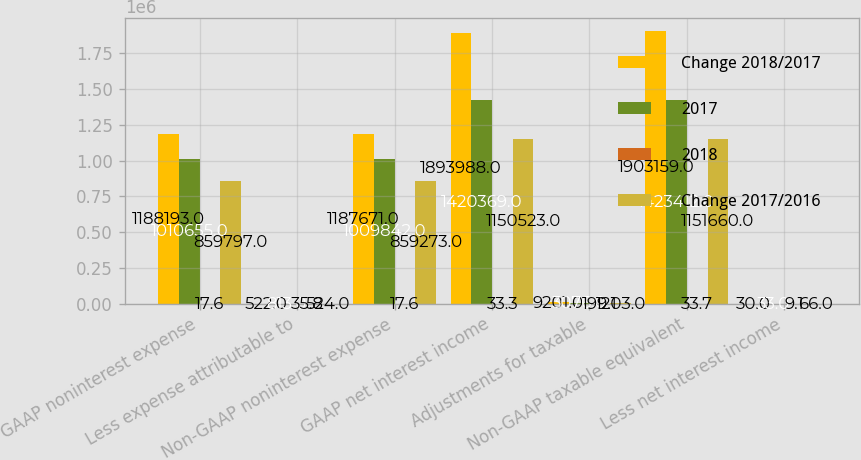<chart> <loc_0><loc_0><loc_500><loc_500><stacked_bar_chart><ecel><fcel>GAAP noninterest expense<fcel>Less expense attributable to<fcel>Non-GAAP noninterest expense<fcel>GAAP net interest income<fcel>Adjustments for taxable<fcel>Non-GAAP taxable equivalent<fcel>Less net interest income<nl><fcel>Change 2018/2017<fcel>1.18819e+06<fcel>522<fcel>1.18767e+06<fcel>1.89399e+06<fcel>9201<fcel>1.90316e+06<fcel>30<nl><fcel>2017<fcel>1.01066e+06<fcel>813<fcel>1.00984e+06<fcel>1.42037e+06<fcel>3076<fcel>1.42341e+06<fcel>33<nl><fcel>2018<fcel>17.6<fcel>35.8<fcel>17.6<fcel>33.3<fcel>199.1<fcel>33.7<fcel>9.1<nl><fcel>Change 2017/2016<fcel>859797<fcel>524<fcel>859273<fcel>1.15052e+06<fcel>1203<fcel>1.15166e+06<fcel>66<nl></chart> 